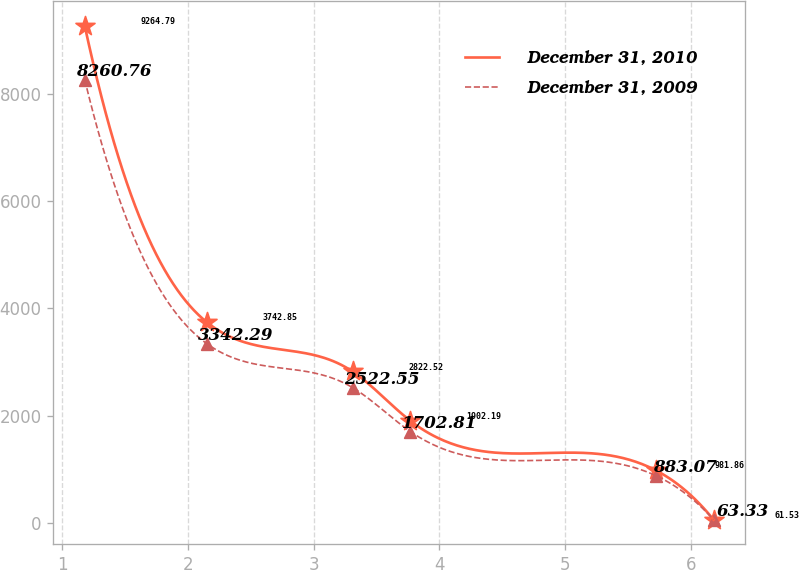Convert chart. <chart><loc_0><loc_0><loc_500><loc_500><line_chart><ecel><fcel>December 31, 2010<fcel>December 31, 2009<nl><fcel>1.18<fcel>9264.79<fcel>8260.76<nl><fcel>2.15<fcel>3742.85<fcel>3342.29<nl><fcel>3.31<fcel>2822.52<fcel>2522.55<nl><fcel>3.77<fcel>1902.19<fcel>1702.81<nl><fcel>5.72<fcel>981.86<fcel>883.07<nl><fcel>6.18<fcel>61.53<fcel>63.33<nl></chart> 